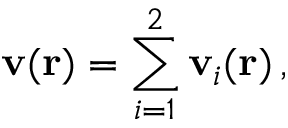<formula> <loc_0><loc_0><loc_500><loc_500>v ( r ) = \sum _ { i = 1 } ^ { 2 } v _ { i } ( r ) \, ,</formula> 